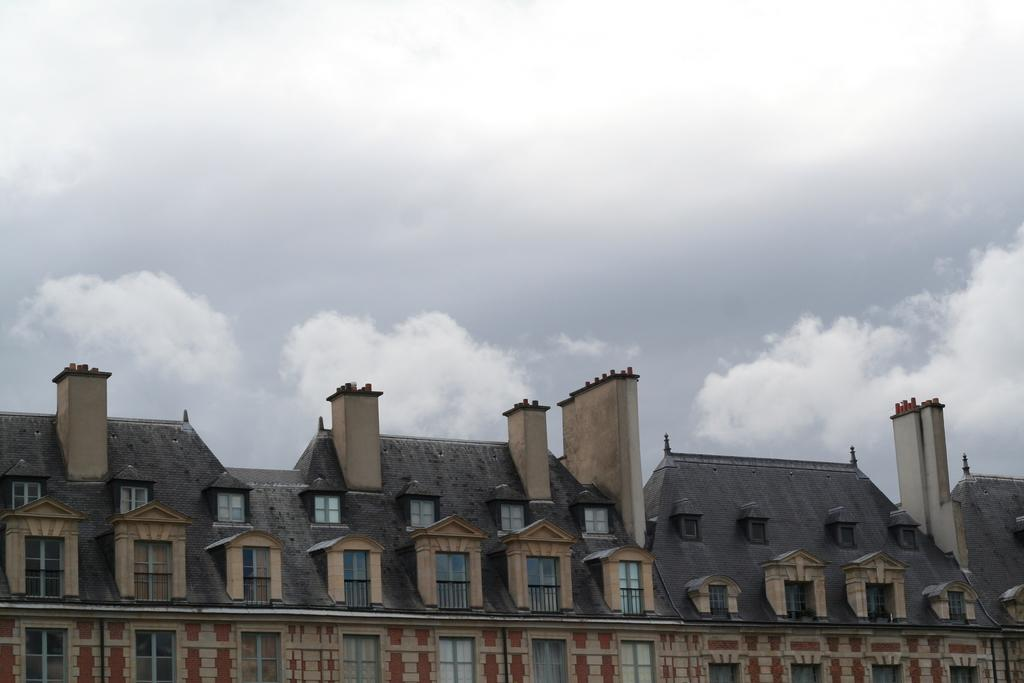What is the main structure in the image? There is a building in the image. What feature can be seen on the building? The building has windows. What is visible in the background of the image? The sky is visible in the image. How would you describe the sky in the image? The sky appears to be cloudy. Can you see a part of the building on fire in the image? No, there is no fire or any part of the building on fire in the image. 